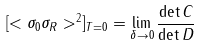Convert formula to latex. <formula><loc_0><loc_0><loc_500><loc_500>[ < \sigma _ { 0 } \sigma _ { R } > ^ { 2 } ] _ { T = 0 } = \lim _ { \delta \rightarrow 0 } \frac { \det C } { \det D }</formula> 